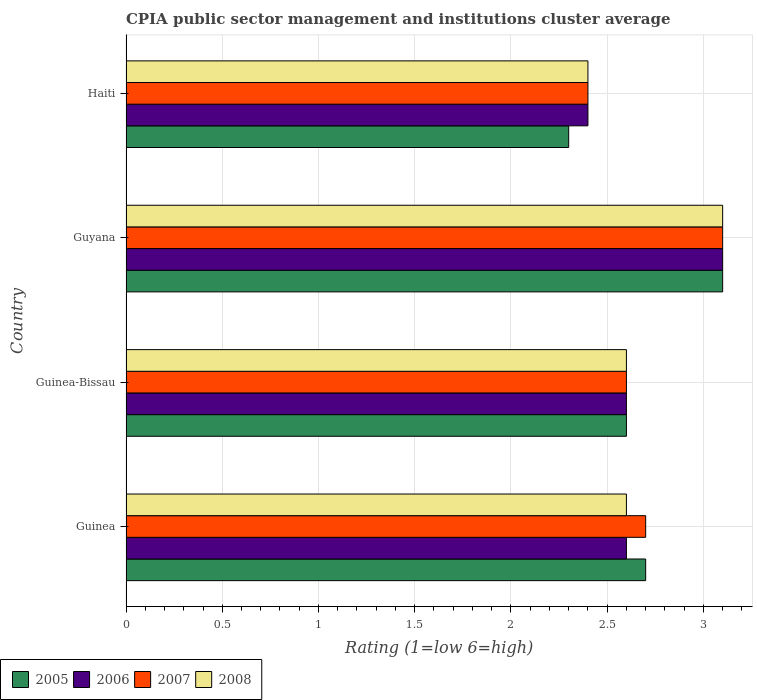Are the number of bars on each tick of the Y-axis equal?
Your answer should be compact. Yes. What is the label of the 3rd group of bars from the top?
Give a very brief answer. Guinea-Bissau. In how many cases, is the number of bars for a given country not equal to the number of legend labels?
Keep it short and to the point. 0. What is the CPIA rating in 2007 in Guyana?
Provide a short and direct response. 3.1. Across all countries, what is the maximum CPIA rating in 2005?
Your response must be concise. 3.1. In which country was the CPIA rating in 2005 maximum?
Offer a very short reply. Guyana. In which country was the CPIA rating in 2007 minimum?
Make the answer very short. Haiti. What is the total CPIA rating in 2008 in the graph?
Offer a very short reply. 10.7. What is the difference between the CPIA rating in 2008 in Guinea-Bissau and that in Haiti?
Make the answer very short. 0.2. What is the difference between the CPIA rating in 2007 in Guinea and the CPIA rating in 2005 in Guyana?
Give a very brief answer. -0.4. What is the average CPIA rating in 2005 per country?
Provide a succinct answer. 2.67. In how many countries, is the CPIA rating in 2005 greater than 0.1 ?
Your answer should be very brief. 4. What is the ratio of the CPIA rating in 2007 in Guinea to that in Haiti?
Make the answer very short. 1.13. What is the difference between the highest and the lowest CPIA rating in 2006?
Provide a succinct answer. 0.7. In how many countries, is the CPIA rating in 2006 greater than the average CPIA rating in 2006 taken over all countries?
Make the answer very short. 1. Is the sum of the CPIA rating in 2006 in Guyana and Haiti greater than the maximum CPIA rating in 2005 across all countries?
Make the answer very short. Yes. Is it the case that in every country, the sum of the CPIA rating in 2007 and CPIA rating in 2005 is greater than the sum of CPIA rating in 2008 and CPIA rating in 2006?
Give a very brief answer. No. What does the 3rd bar from the bottom in Guinea-Bissau represents?
Give a very brief answer. 2007. How many bars are there?
Provide a succinct answer. 16. Are all the bars in the graph horizontal?
Give a very brief answer. Yes. Are the values on the major ticks of X-axis written in scientific E-notation?
Give a very brief answer. No. Does the graph contain grids?
Offer a terse response. Yes. Where does the legend appear in the graph?
Your answer should be compact. Bottom left. What is the title of the graph?
Provide a short and direct response. CPIA public sector management and institutions cluster average. Does "2001" appear as one of the legend labels in the graph?
Provide a short and direct response. No. What is the label or title of the X-axis?
Give a very brief answer. Rating (1=low 6=high). What is the Rating (1=low 6=high) of 2005 in Guinea?
Keep it short and to the point. 2.7. What is the Rating (1=low 6=high) of 2007 in Guinea?
Ensure brevity in your answer.  2.7. What is the Rating (1=low 6=high) in 2005 in Guinea-Bissau?
Keep it short and to the point. 2.6. What is the Rating (1=low 6=high) in 2006 in Guinea-Bissau?
Your answer should be compact. 2.6. What is the Rating (1=low 6=high) of 2007 in Guinea-Bissau?
Ensure brevity in your answer.  2.6. What is the Rating (1=low 6=high) in 2005 in Haiti?
Your response must be concise. 2.3. What is the Rating (1=low 6=high) in 2006 in Haiti?
Offer a terse response. 2.4. What is the Rating (1=low 6=high) of 2008 in Haiti?
Provide a short and direct response. 2.4. Across all countries, what is the maximum Rating (1=low 6=high) in 2008?
Offer a terse response. 3.1. What is the total Rating (1=low 6=high) of 2005 in the graph?
Your answer should be compact. 10.7. What is the total Rating (1=low 6=high) of 2008 in the graph?
Keep it short and to the point. 10.7. What is the difference between the Rating (1=low 6=high) of 2005 in Guinea and that in Guinea-Bissau?
Make the answer very short. 0.1. What is the difference between the Rating (1=low 6=high) of 2007 in Guinea and that in Guinea-Bissau?
Make the answer very short. 0.1. What is the difference between the Rating (1=low 6=high) in 2008 in Guinea and that in Guyana?
Offer a terse response. -0.5. What is the difference between the Rating (1=low 6=high) in 2005 in Guinea and that in Haiti?
Your answer should be very brief. 0.4. What is the difference between the Rating (1=low 6=high) of 2007 in Guinea and that in Haiti?
Offer a very short reply. 0.3. What is the difference between the Rating (1=low 6=high) in 2008 in Guinea and that in Haiti?
Your answer should be very brief. 0.2. What is the difference between the Rating (1=low 6=high) of 2006 in Guinea-Bissau and that in Haiti?
Keep it short and to the point. 0.2. What is the difference between the Rating (1=low 6=high) in 2007 in Guinea-Bissau and that in Haiti?
Provide a succinct answer. 0.2. What is the difference between the Rating (1=low 6=high) of 2008 in Guinea-Bissau and that in Haiti?
Give a very brief answer. 0.2. What is the difference between the Rating (1=low 6=high) in 2005 in Guyana and that in Haiti?
Make the answer very short. 0.8. What is the difference between the Rating (1=low 6=high) in 2007 in Guyana and that in Haiti?
Provide a succinct answer. 0.7. What is the difference between the Rating (1=low 6=high) of 2005 in Guinea and the Rating (1=low 6=high) of 2007 in Guinea-Bissau?
Your answer should be very brief. 0.1. What is the difference between the Rating (1=low 6=high) of 2005 in Guinea and the Rating (1=low 6=high) of 2008 in Guinea-Bissau?
Provide a succinct answer. 0.1. What is the difference between the Rating (1=low 6=high) of 2006 in Guinea and the Rating (1=low 6=high) of 2007 in Guinea-Bissau?
Ensure brevity in your answer.  0. What is the difference between the Rating (1=low 6=high) in 2006 in Guinea and the Rating (1=low 6=high) in 2007 in Guyana?
Your answer should be compact. -0.5. What is the difference between the Rating (1=low 6=high) of 2006 in Guinea and the Rating (1=low 6=high) of 2008 in Guyana?
Your answer should be very brief. -0.5. What is the difference between the Rating (1=low 6=high) of 2007 in Guinea and the Rating (1=low 6=high) of 2008 in Guyana?
Provide a short and direct response. -0.4. What is the difference between the Rating (1=low 6=high) of 2006 in Guinea and the Rating (1=low 6=high) of 2007 in Haiti?
Your response must be concise. 0.2. What is the difference between the Rating (1=low 6=high) of 2007 in Guinea and the Rating (1=low 6=high) of 2008 in Haiti?
Your answer should be compact. 0.3. What is the difference between the Rating (1=low 6=high) in 2005 in Guinea-Bissau and the Rating (1=low 6=high) in 2007 in Guyana?
Your response must be concise. -0.5. What is the difference between the Rating (1=low 6=high) in 2006 in Guinea-Bissau and the Rating (1=low 6=high) in 2007 in Guyana?
Ensure brevity in your answer.  -0.5. What is the difference between the Rating (1=low 6=high) in 2006 in Guinea-Bissau and the Rating (1=low 6=high) in 2008 in Guyana?
Offer a terse response. -0.5. What is the difference between the Rating (1=low 6=high) of 2005 in Guinea-Bissau and the Rating (1=low 6=high) of 2008 in Haiti?
Provide a short and direct response. 0.2. What is the difference between the Rating (1=low 6=high) in 2006 in Guinea-Bissau and the Rating (1=low 6=high) in 2007 in Haiti?
Make the answer very short. 0.2. What is the difference between the Rating (1=low 6=high) in 2005 in Guyana and the Rating (1=low 6=high) in 2008 in Haiti?
Offer a terse response. 0.7. What is the difference between the Rating (1=low 6=high) in 2006 in Guyana and the Rating (1=low 6=high) in 2007 in Haiti?
Offer a terse response. 0.7. What is the difference between the Rating (1=low 6=high) of 2006 in Guyana and the Rating (1=low 6=high) of 2008 in Haiti?
Make the answer very short. 0.7. What is the difference between the Rating (1=low 6=high) in 2007 in Guyana and the Rating (1=low 6=high) in 2008 in Haiti?
Keep it short and to the point. 0.7. What is the average Rating (1=low 6=high) of 2005 per country?
Your answer should be compact. 2.67. What is the average Rating (1=low 6=high) in 2006 per country?
Ensure brevity in your answer.  2.67. What is the average Rating (1=low 6=high) in 2008 per country?
Make the answer very short. 2.67. What is the difference between the Rating (1=low 6=high) of 2005 and Rating (1=low 6=high) of 2006 in Guinea?
Offer a very short reply. 0.1. What is the difference between the Rating (1=low 6=high) in 2006 and Rating (1=low 6=high) in 2007 in Guinea?
Keep it short and to the point. -0.1. What is the difference between the Rating (1=low 6=high) in 2006 and Rating (1=low 6=high) in 2008 in Guinea?
Ensure brevity in your answer.  0. What is the difference between the Rating (1=low 6=high) in 2007 and Rating (1=low 6=high) in 2008 in Guinea?
Provide a succinct answer. 0.1. What is the difference between the Rating (1=low 6=high) of 2005 and Rating (1=low 6=high) of 2006 in Guinea-Bissau?
Offer a terse response. 0. What is the difference between the Rating (1=low 6=high) in 2005 and Rating (1=low 6=high) in 2007 in Guinea-Bissau?
Ensure brevity in your answer.  0. What is the difference between the Rating (1=low 6=high) of 2005 and Rating (1=low 6=high) of 2008 in Guinea-Bissau?
Ensure brevity in your answer.  0. What is the difference between the Rating (1=low 6=high) of 2006 and Rating (1=low 6=high) of 2008 in Guinea-Bissau?
Give a very brief answer. 0. What is the difference between the Rating (1=low 6=high) in 2007 and Rating (1=low 6=high) in 2008 in Guinea-Bissau?
Keep it short and to the point. 0. What is the difference between the Rating (1=low 6=high) in 2005 and Rating (1=low 6=high) in 2006 in Guyana?
Make the answer very short. 0. What is the difference between the Rating (1=low 6=high) of 2006 and Rating (1=low 6=high) of 2008 in Guyana?
Offer a very short reply. 0. What is the difference between the Rating (1=low 6=high) in 2005 and Rating (1=low 6=high) in 2006 in Haiti?
Provide a succinct answer. -0.1. What is the difference between the Rating (1=low 6=high) in 2005 and Rating (1=low 6=high) in 2008 in Haiti?
Your answer should be compact. -0.1. What is the difference between the Rating (1=low 6=high) in 2006 and Rating (1=low 6=high) in 2008 in Haiti?
Offer a very short reply. 0. What is the ratio of the Rating (1=low 6=high) of 2005 in Guinea to that in Guinea-Bissau?
Your answer should be compact. 1.04. What is the ratio of the Rating (1=low 6=high) in 2006 in Guinea to that in Guinea-Bissau?
Your answer should be compact. 1. What is the ratio of the Rating (1=low 6=high) of 2007 in Guinea to that in Guinea-Bissau?
Make the answer very short. 1.04. What is the ratio of the Rating (1=low 6=high) of 2008 in Guinea to that in Guinea-Bissau?
Give a very brief answer. 1. What is the ratio of the Rating (1=low 6=high) in 2005 in Guinea to that in Guyana?
Offer a terse response. 0.87. What is the ratio of the Rating (1=low 6=high) of 2006 in Guinea to that in Guyana?
Provide a short and direct response. 0.84. What is the ratio of the Rating (1=low 6=high) in 2007 in Guinea to that in Guyana?
Ensure brevity in your answer.  0.87. What is the ratio of the Rating (1=low 6=high) in 2008 in Guinea to that in Guyana?
Offer a terse response. 0.84. What is the ratio of the Rating (1=low 6=high) of 2005 in Guinea to that in Haiti?
Your response must be concise. 1.17. What is the ratio of the Rating (1=low 6=high) in 2007 in Guinea to that in Haiti?
Provide a short and direct response. 1.12. What is the ratio of the Rating (1=low 6=high) of 2008 in Guinea to that in Haiti?
Provide a succinct answer. 1.08. What is the ratio of the Rating (1=low 6=high) of 2005 in Guinea-Bissau to that in Guyana?
Provide a short and direct response. 0.84. What is the ratio of the Rating (1=low 6=high) in 2006 in Guinea-Bissau to that in Guyana?
Your answer should be compact. 0.84. What is the ratio of the Rating (1=low 6=high) in 2007 in Guinea-Bissau to that in Guyana?
Your answer should be compact. 0.84. What is the ratio of the Rating (1=low 6=high) in 2008 in Guinea-Bissau to that in Guyana?
Your answer should be very brief. 0.84. What is the ratio of the Rating (1=low 6=high) of 2005 in Guinea-Bissau to that in Haiti?
Give a very brief answer. 1.13. What is the ratio of the Rating (1=low 6=high) of 2006 in Guinea-Bissau to that in Haiti?
Offer a very short reply. 1.08. What is the ratio of the Rating (1=low 6=high) in 2007 in Guinea-Bissau to that in Haiti?
Ensure brevity in your answer.  1.08. What is the ratio of the Rating (1=low 6=high) in 2005 in Guyana to that in Haiti?
Keep it short and to the point. 1.35. What is the ratio of the Rating (1=low 6=high) of 2006 in Guyana to that in Haiti?
Provide a succinct answer. 1.29. What is the ratio of the Rating (1=low 6=high) of 2007 in Guyana to that in Haiti?
Your answer should be very brief. 1.29. What is the ratio of the Rating (1=low 6=high) of 2008 in Guyana to that in Haiti?
Provide a short and direct response. 1.29. What is the difference between the highest and the second highest Rating (1=low 6=high) of 2006?
Keep it short and to the point. 0.5. What is the difference between the highest and the second highest Rating (1=low 6=high) of 2007?
Ensure brevity in your answer.  0.4. What is the difference between the highest and the second highest Rating (1=low 6=high) of 2008?
Offer a very short reply. 0.5. What is the difference between the highest and the lowest Rating (1=low 6=high) in 2005?
Give a very brief answer. 0.8. What is the difference between the highest and the lowest Rating (1=low 6=high) of 2006?
Make the answer very short. 0.7. What is the difference between the highest and the lowest Rating (1=low 6=high) of 2007?
Make the answer very short. 0.7. What is the difference between the highest and the lowest Rating (1=low 6=high) in 2008?
Your answer should be compact. 0.7. 